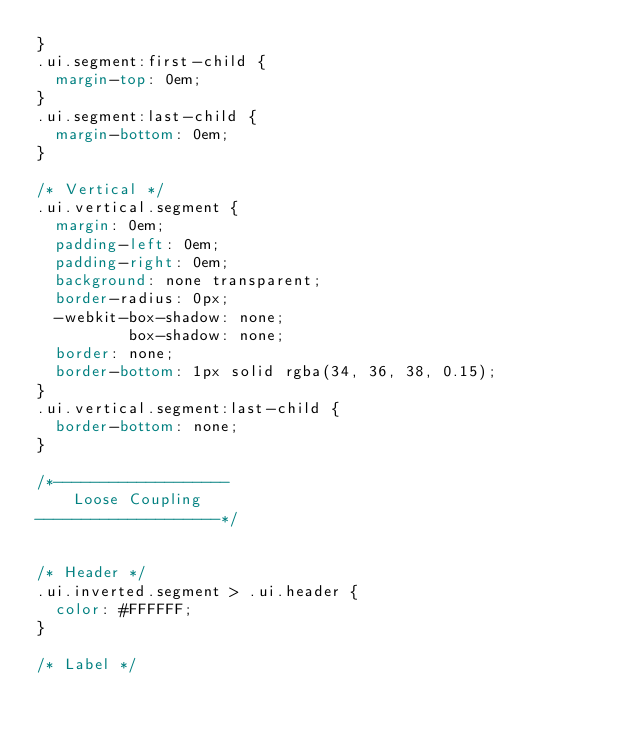Convert code to text. <code><loc_0><loc_0><loc_500><loc_500><_CSS_>}
.ui.segment:first-child {
  margin-top: 0em;
}
.ui.segment:last-child {
  margin-bottom: 0em;
}

/* Vertical */
.ui.vertical.segment {
  margin: 0em;
  padding-left: 0em;
  padding-right: 0em;
  background: none transparent;
  border-radius: 0px;
  -webkit-box-shadow: none;
          box-shadow: none;
  border: none;
  border-bottom: 1px solid rgba(34, 36, 38, 0.15);
}
.ui.vertical.segment:last-child {
  border-bottom: none;
}

/*-------------------
    Loose Coupling
--------------------*/


/* Header */
.ui.inverted.segment > .ui.header {
  color: #FFFFFF;
}

/* Label */</code> 